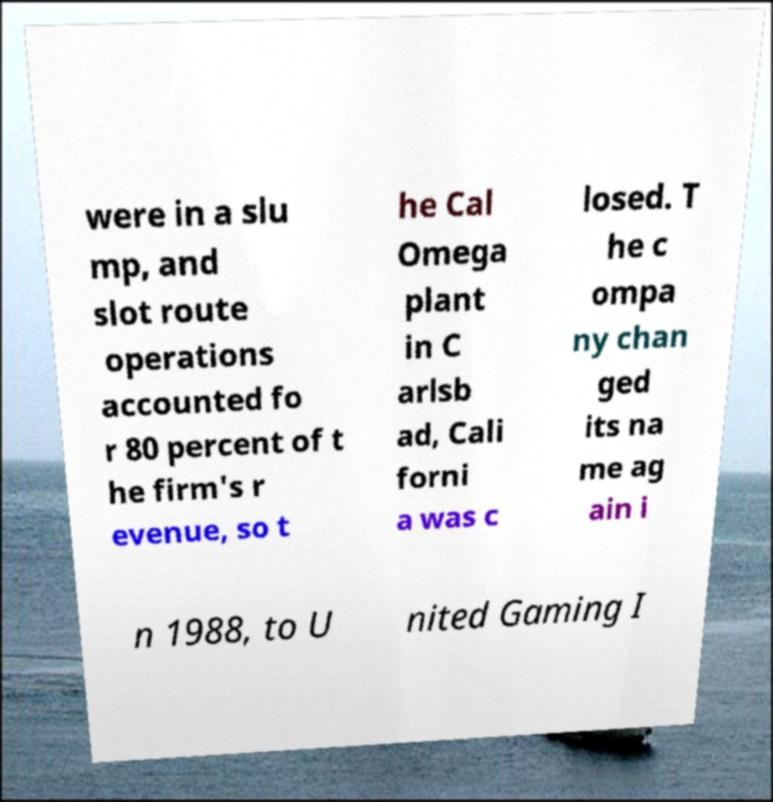Could you assist in decoding the text presented in this image and type it out clearly? were in a slu mp, and slot route operations accounted fo r 80 percent of t he firm's r evenue, so t he Cal Omega plant in C arlsb ad, Cali forni a was c losed. T he c ompa ny chan ged its na me ag ain i n 1988, to U nited Gaming I 